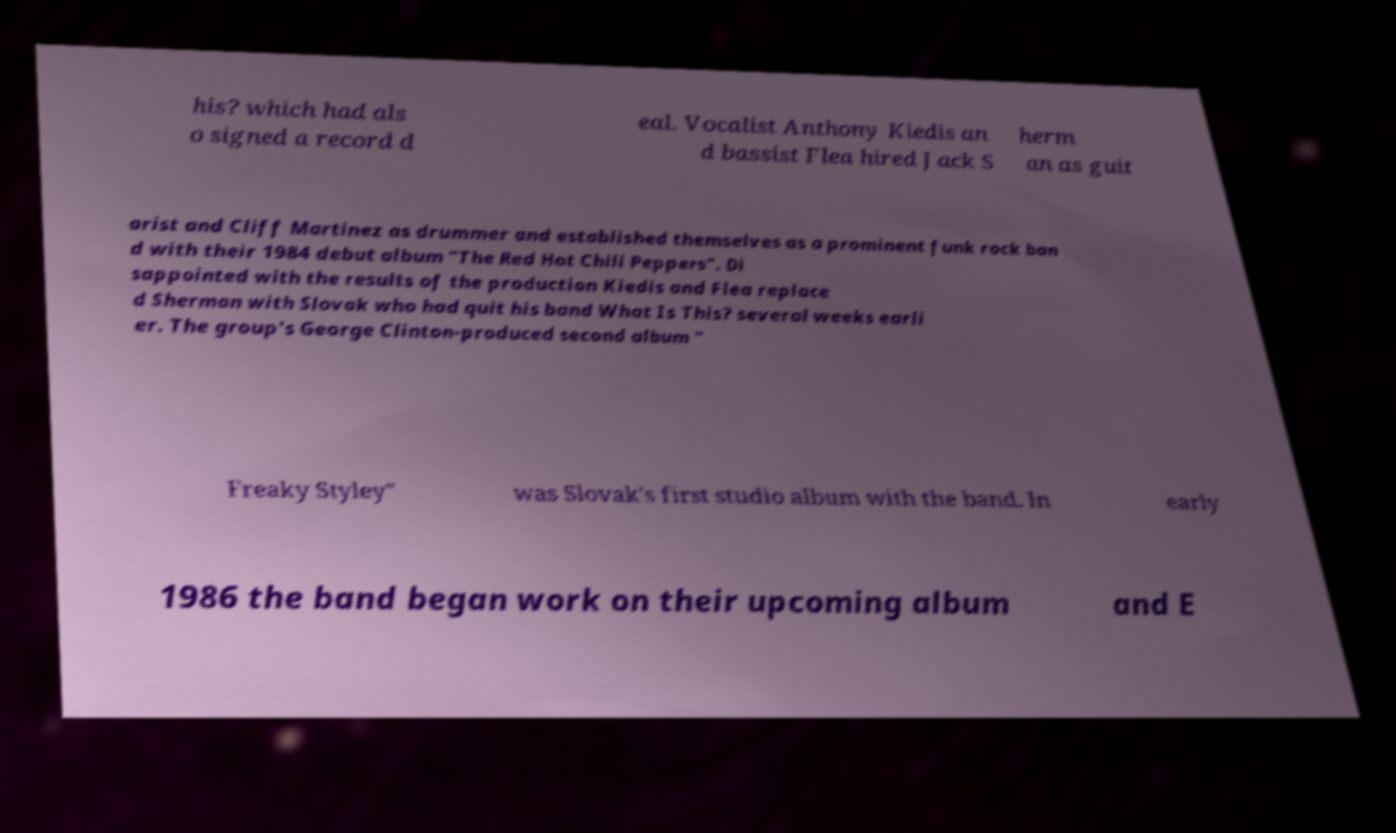I need the written content from this picture converted into text. Can you do that? his? which had als o signed a record d eal. Vocalist Anthony Kiedis an d bassist Flea hired Jack S herm an as guit arist and Cliff Martinez as drummer and established themselves as a prominent funk rock ban d with their 1984 debut album "The Red Hot Chili Peppers". Di sappointed with the results of the production Kiedis and Flea replace d Sherman with Slovak who had quit his band What Is This? several weeks earli er. The group's George Clinton-produced second album " Freaky Styley" was Slovak's first studio album with the band. In early 1986 the band began work on their upcoming album and E 